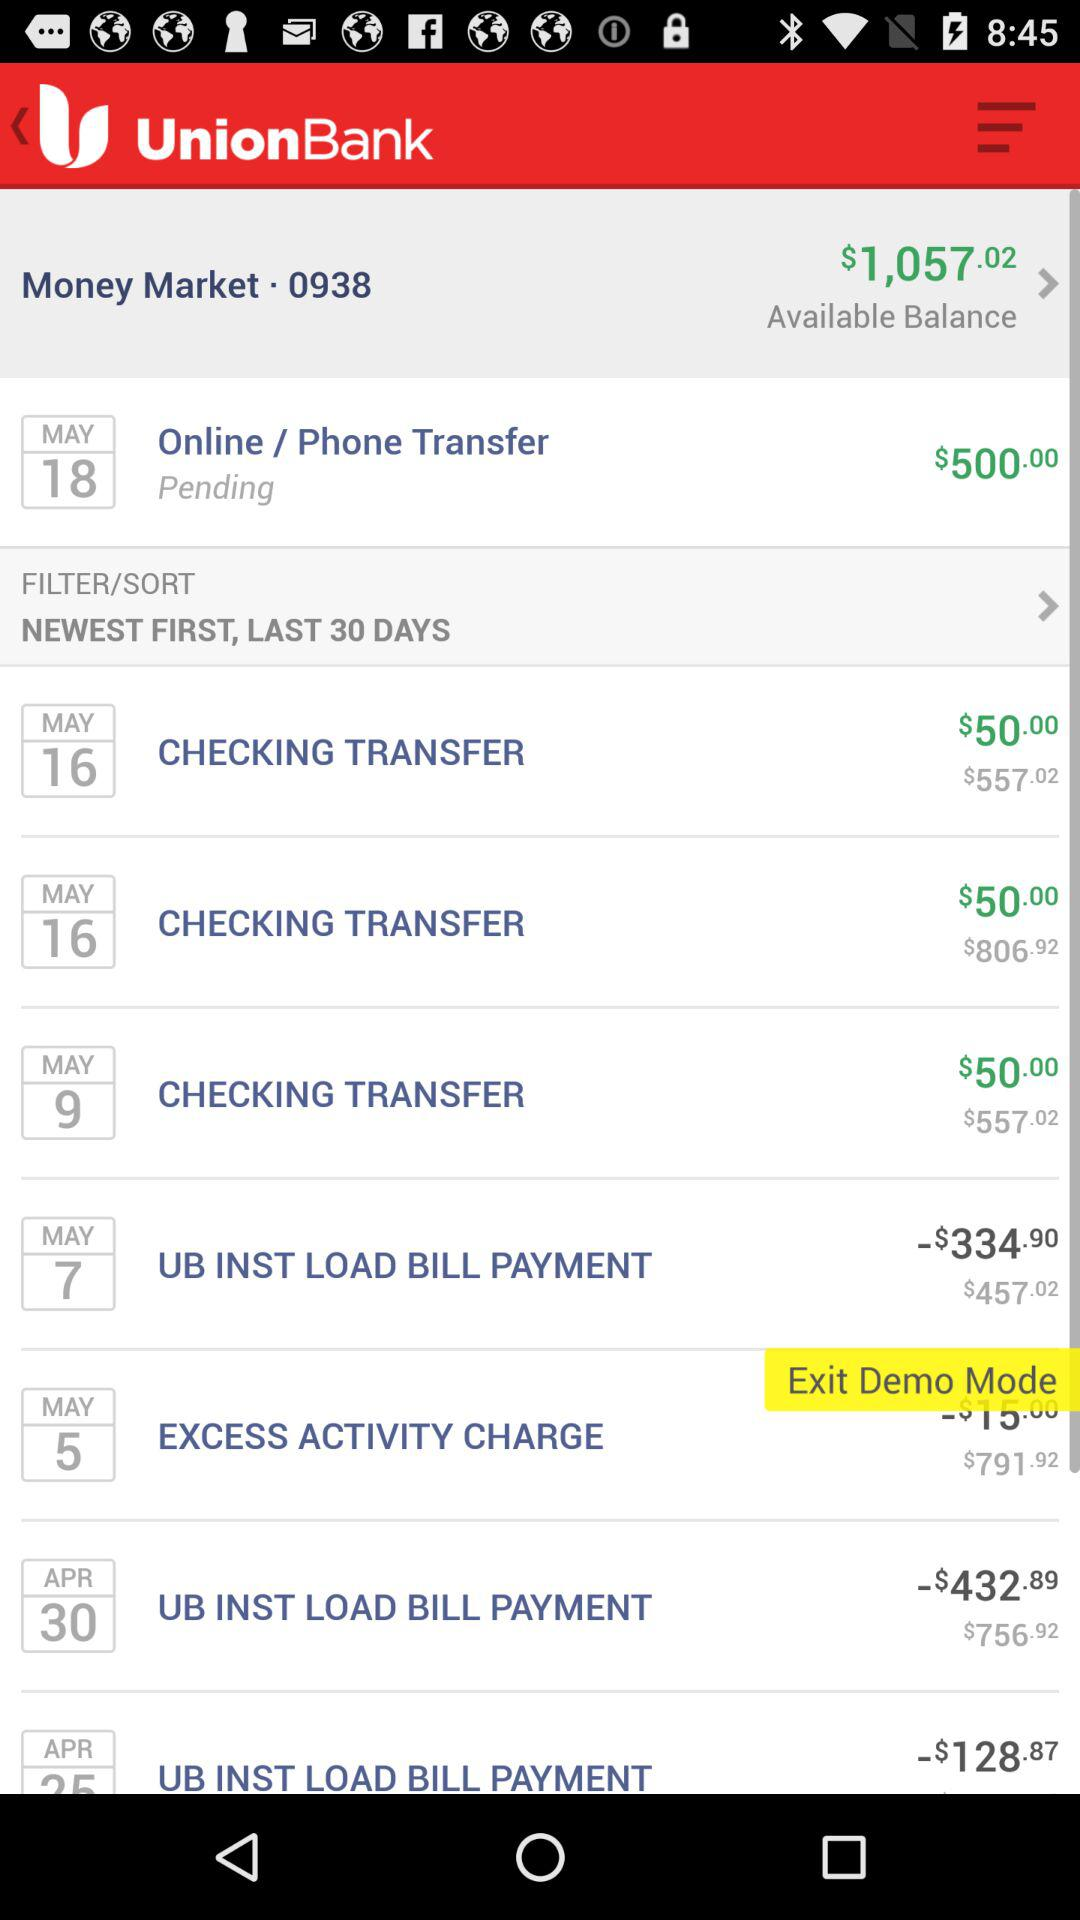How much balance is available? The available balance is $1,057.02. 